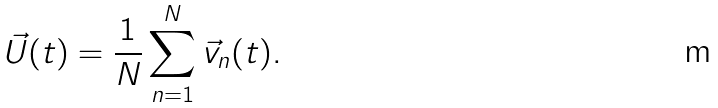<formula> <loc_0><loc_0><loc_500><loc_500>\vec { U } ( t ) = \frac { 1 } { N } \sum _ { n = 1 } ^ { N } \vec { v } _ { n } ( t ) .</formula> 